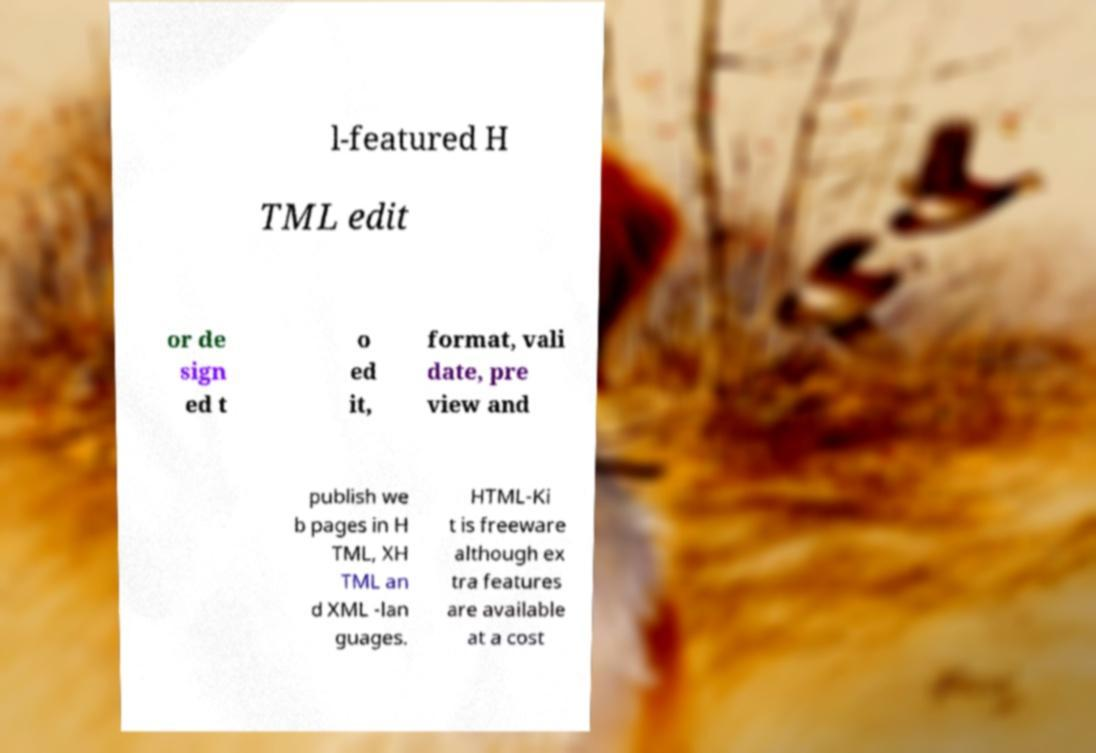Please identify and transcribe the text found in this image. l-featured H TML edit or de sign ed t o ed it, format, vali date, pre view and publish we b pages in H TML, XH TML an d XML -lan guages. HTML-Ki t is freeware although ex tra features are available at a cost 